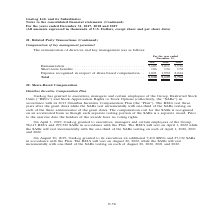From Gaslog's financial document, In which years was the remuneration of directors and key management recorded for? The document contains multiple relevant values: 2017, 2018, 2019. From the document: "For the year ended December 31, 2017 2018 2019 For the year ended December 31, 2017 2018 2019 For the year ended December 31, 2017 2018 2019..." Also, What is the expense recognized in respect of share-based compensation in 2017? According to the financial document, 1,821 (in thousands). The relevant text states: "cognized in respect of share-based compensation . 1,821 1,992 2,044 Total . 9,530 9,139 9,752..." Also, What was the remuneration in 2018? According to the financial document, 7,011 (in thousands). The relevant text states: "Remuneration . 7,603 7,011 7,536 Short-term benefits . 106 136 172 Expense recognized in respect of share-based compensation ...." Additionally, Which year was the short-term benefits the highest? According to the financial document, 2019. The relevant text states: "For the year ended December 31, 2017 2018 2019..." Also, can you calculate: What was the change in the total from 2017 to 2019? Based on the calculation: 9,752 - 9,530 , the result is 222 (in thousands). This is based on the information: "pensation . 1,821 1,992 2,044 Total . 9,530 9,139 9,752 re-based compensation . 1,821 1,992 2,044 Total . 9,530 9,139 9,752..." The key data points involved are: 9,530, 9,752. Also, can you calculate: What was the percentage change in remuneration from 2018 to 2019? To answer this question, I need to perform calculations using the financial data. The calculation is: (7,536 - 7,011)/7,011 , which equals 7.49 (percentage). This is based on the information: "Remuneration . 7,603 7,011 7,536 Short-term benefits . 106 136 172 Expense recognized in respect of share-based compensation . Remuneration . 7,603 7,011 7,536 Short-term benefits . 106 136 172 Expens..." The key data points involved are: 7,011, 7,536. 